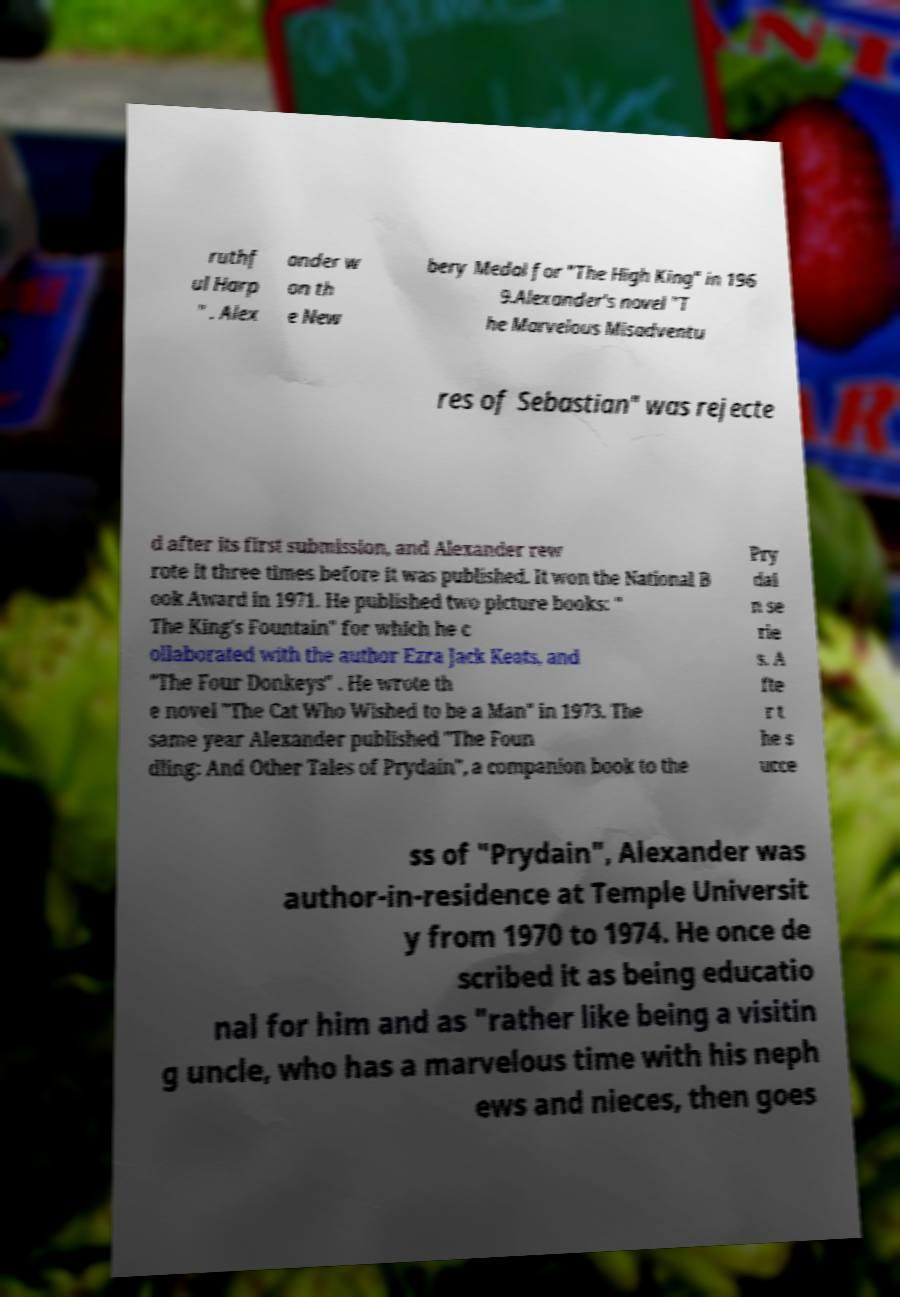Please read and relay the text visible in this image. What does it say? ruthf ul Harp " . Alex ander w on th e New bery Medal for "The High King" in 196 9.Alexander's novel "T he Marvelous Misadventu res of Sebastian" was rejecte d after its first submission, and Alexander rew rote it three times before it was published. It won the National B ook Award in 1971. He published two picture books: " The King's Fountain" for which he c ollaborated with the author Ezra Jack Keats, and "The Four Donkeys" . He wrote th e novel "The Cat Who Wished to be a Man" in 1973. The same year Alexander published "The Foun dling: And Other Tales of Prydain", a companion book to the Pry dai n se rie s. A fte r t he s ucce ss of "Prydain", Alexander was author-in-residence at Temple Universit y from 1970 to 1974. He once de scribed it as being educatio nal for him and as "rather like being a visitin g uncle, who has a marvelous time with his neph ews and nieces, then goes 